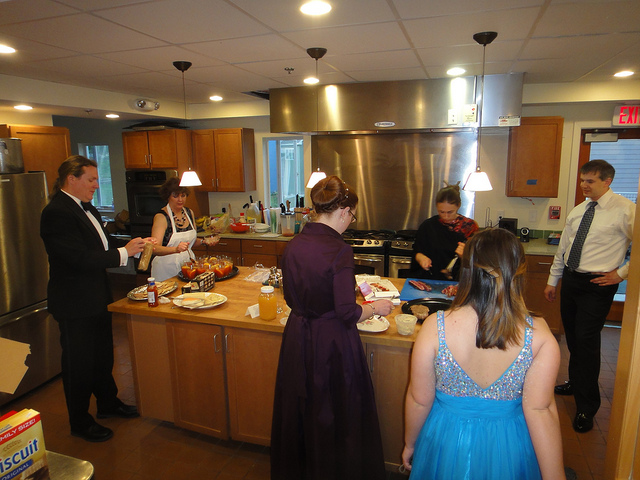Please extract the text content from this image. EXT Biscuit 